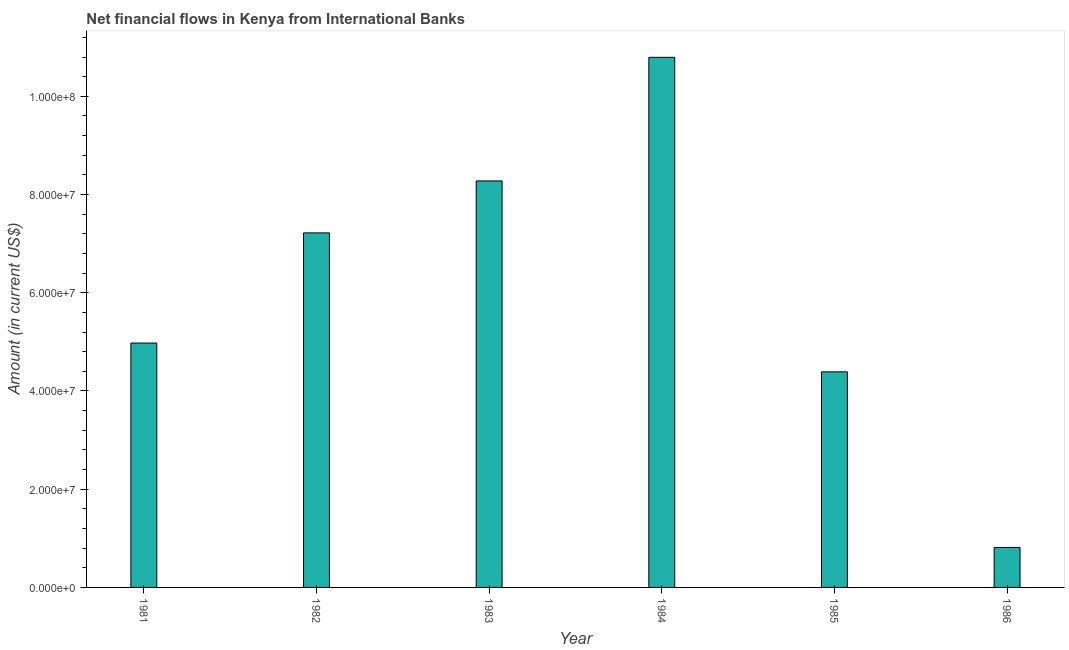Does the graph contain any zero values?
Give a very brief answer. No. What is the title of the graph?
Your answer should be compact. Net financial flows in Kenya from International Banks. What is the net financial flows from ibrd in 1984?
Keep it short and to the point. 1.08e+08. Across all years, what is the maximum net financial flows from ibrd?
Give a very brief answer. 1.08e+08. Across all years, what is the minimum net financial flows from ibrd?
Offer a terse response. 8.14e+06. In which year was the net financial flows from ibrd maximum?
Your answer should be very brief. 1984. What is the sum of the net financial flows from ibrd?
Keep it short and to the point. 3.65e+08. What is the difference between the net financial flows from ibrd in 1985 and 1986?
Your answer should be very brief. 3.58e+07. What is the average net financial flows from ibrd per year?
Offer a terse response. 6.08e+07. What is the median net financial flows from ibrd?
Give a very brief answer. 6.10e+07. What is the ratio of the net financial flows from ibrd in 1981 to that in 1982?
Give a very brief answer. 0.69. Is the net financial flows from ibrd in 1981 less than that in 1985?
Keep it short and to the point. No. Is the difference between the net financial flows from ibrd in 1982 and 1984 greater than the difference between any two years?
Your response must be concise. No. What is the difference between the highest and the second highest net financial flows from ibrd?
Give a very brief answer. 2.52e+07. Is the sum of the net financial flows from ibrd in 1983 and 1985 greater than the maximum net financial flows from ibrd across all years?
Keep it short and to the point. Yes. What is the difference between the highest and the lowest net financial flows from ibrd?
Offer a terse response. 9.98e+07. How many bars are there?
Keep it short and to the point. 6. Are all the bars in the graph horizontal?
Your answer should be compact. No. How many years are there in the graph?
Your answer should be compact. 6. Are the values on the major ticks of Y-axis written in scientific E-notation?
Provide a succinct answer. Yes. What is the Amount (in current US$) of 1981?
Offer a terse response. 4.98e+07. What is the Amount (in current US$) of 1982?
Ensure brevity in your answer.  7.22e+07. What is the Amount (in current US$) in 1983?
Make the answer very short. 8.28e+07. What is the Amount (in current US$) of 1984?
Provide a short and direct response. 1.08e+08. What is the Amount (in current US$) of 1985?
Ensure brevity in your answer.  4.39e+07. What is the Amount (in current US$) of 1986?
Your response must be concise. 8.14e+06. What is the difference between the Amount (in current US$) in 1981 and 1982?
Make the answer very short. -2.24e+07. What is the difference between the Amount (in current US$) in 1981 and 1983?
Your answer should be very brief. -3.30e+07. What is the difference between the Amount (in current US$) in 1981 and 1984?
Your response must be concise. -5.82e+07. What is the difference between the Amount (in current US$) in 1981 and 1985?
Make the answer very short. 5.86e+06. What is the difference between the Amount (in current US$) in 1981 and 1986?
Keep it short and to the point. 4.16e+07. What is the difference between the Amount (in current US$) in 1982 and 1983?
Your answer should be compact. -1.06e+07. What is the difference between the Amount (in current US$) in 1982 and 1984?
Your answer should be very brief. -3.57e+07. What is the difference between the Amount (in current US$) in 1982 and 1985?
Your answer should be compact. 2.83e+07. What is the difference between the Amount (in current US$) in 1982 and 1986?
Offer a very short reply. 6.41e+07. What is the difference between the Amount (in current US$) in 1983 and 1984?
Provide a short and direct response. -2.52e+07. What is the difference between the Amount (in current US$) in 1983 and 1985?
Provide a short and direct response. 3.89e+07. What is the difference between the Amount (in current US$) in 1983 and 1986?
Ensure brevity in your answer.  7.46e+07. What is the difference between the Amount (in current US$) in 1984 and 1985?
Provide a succinct answer. 6.40e+07. What is the difference between the Amount (in current US$) in 1984 and 1986?
Provide a succinct answer. 9.98e+07. What is the difference between the Amount (in current US$) in 1985 and 1986?
Provide a succinct answer. 3.58e+07. What is the ratio of the Amount (in current US$) in 1981 to that in 1982?
Keep it short and to the point. 0.69. What is the ratio of the Amount (in current US$) in 1981 to that in 1983?
Provide a succinct answer. 0.6. What is the ratio of the Amount (in current US$) in 1981 to that in 1984?
Give a very brief answer. 0.46. What is the ratio of the Amount (in current US$) in 1981 to that in 1985?
Keep it short and to the point. 1.13. What is the ratio of the Amount (in current US$) in 1981 to that in 1986?
Make the answer very short. 6.11. What is the ratio of the Amount (in current US$) in 1982 to that in 1983?
Provide a short and direct response. 0.87. What is the ratio of the Amount (in current US$) in 1982 to that in 1984?
Your answer should be compact. 0.67. What is the ratio of the Amount (in current US$) in 1982 to that in 1985?
Keep it short and to the point. 1.65. What is the ratio of the Amount (in current US$) in 1982 to that in 1986?
Your response must be concise. 8.87. What is the ratio of the Amount (in current US$) in 1983 to that in 1984?
Provide a short and direct response. 0.77. What is the ratio of the Amount (in current US$) in 1983 to that in 1985?
Your answer should be very brief. 1.89. What is the ratio of the Amount (in current US$) in 1983 to that in 1986?
Offer a very short reply. 10.16. What is the ratio of the Amount (in current US$) in 1984 to that in 1985?
Provide a succinct answer. 2.46. What is the ratio of the Amount (in current US$) in 1984 to that in 1986?
Offer a very short reply. 13.26. What is the ratio of the Amount (in current US$) in 1985 to that in 1986?
Provide a short and direct response. 5.39. 